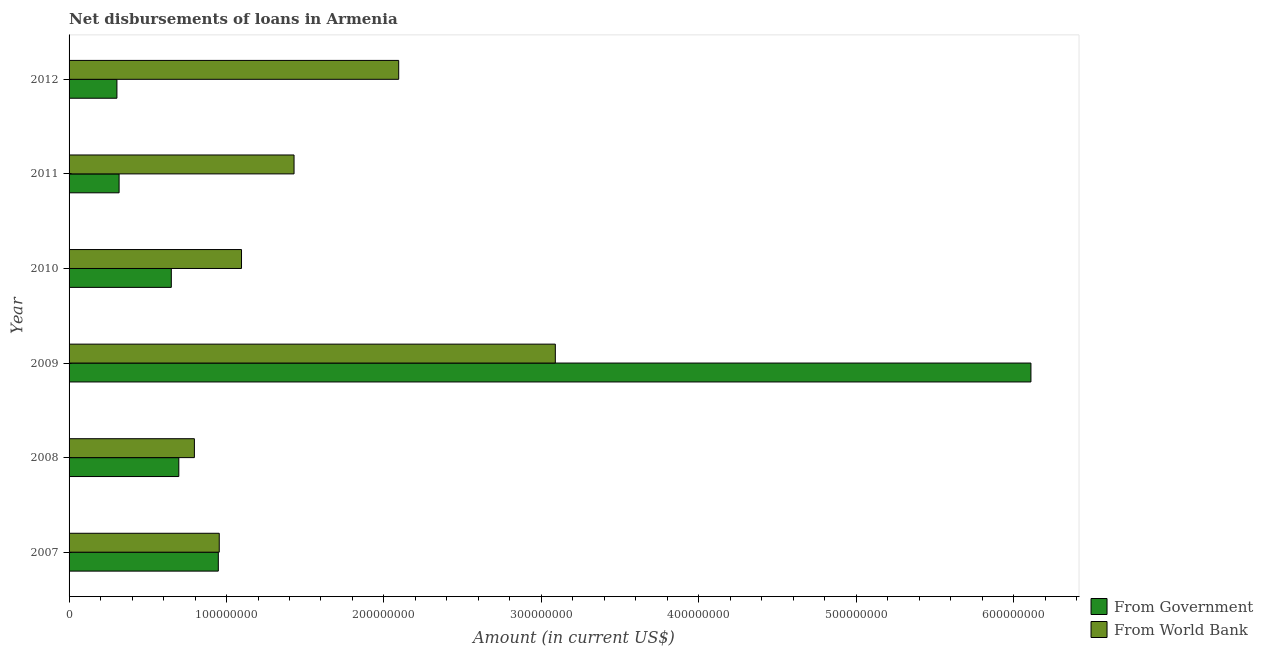How many groups of bars are there?
Provide a short and direct response. 6. Are the number of bars per tick equal to the number of legend labels?
Provide a succinct answer. Yes. Are the number of bars on each tick of the Y-axis equal?
Offer a terse response. Yes. How many bars are there on the 4th tick from the bottom?
Your answer should be compact. 2. What is the net disbursements of loan from government in 2008?
Your response must be concise. 6.97e+07. Across all years, what is the maximum net disbursements of loan from world bank?
Your answer should be very brief. 3.09e+08. Across all years, what is the minimum net disbursements of loan from government?
Give a very brief answer. 3.04e+07. In which year was the net disbursements of loan from world bank maximum?
Provide a succinct answer. 2009. In which year was the net disbursements of loan from world bank minimum?
Your answer should be compact. 2008. What is the total net disbursements of loan from government in the graph?
Give a very brief answer. 9.02e+08. What is the difference between the net disbursements of loan from government in 2007 and that in 2009?
Provide a succinct answer. -5.16e+08. What is the difference between the net disbursements of loan from government in 2007 and the net disbursements of loan from world bank in 2010?
Provide a short and direct response. -1.47e+07. What is the average net disbursements of loan from world bank per year?
Your response must be concise. 1.58e+08. In the year 2012, what is the difference between the net disbursements of loan from government and net disbursements of loan from world bank?
Make the answer very short. -1.79e+08. What is the ratio of the net disbursements of loan from world bank in 2009 to that in 2011?
Your answer should be compact. 2.16. What is the difference between the highest and the second highest net disbursements of loan from world bank?
Your answer should be compact. 9.95e+07. What is the difference between the highest and the lowest net disbursements of loan from world bank?
Provide a short and direct response. 2.29e+08. What does the 1st bar from the top in 2011 represents?
Offer a terse response. From World Bank. What does the 2nd bar from the bottom in 2009 represents?
Provide a short and direct response. From World Bank. How many bars are there?
Keep it short and to the point. 12. Are all the bars in the graph horizontal?
Provide a succinct answer. Yes. How many years are there in the graph?
Offer a terse response. 6. Does the graph contain any zero values?
Your response must be concise. No. Where does the legend appear in the graph?
Give a very brief answer. Bottom right. How many legend labels are there?
Provide a short and direct response. 2. How are the legend labels stacked?
Ensure brevity in your answer.  Vertical. What is the title of the graph?
Your answer should be very brief. Net disbursements of loans in Armenia. Does "Automatic Teller Machines" appear as one of the legend labels in the graph?
Your answer should be very brief. No. What is the label or title of the Y-axis?
Your answer should be very brief. Year. What is the Amount (in current US$) of From Government in 2007?
Keep it short and to the point. 9.48e+07. What is the Amount (in current US$) in From World Bank in 2007?
Ensure brevity in your answer.  9.54e+07. What is the Amount (in current US$) of From Government in 2008?
Provide a short and direct response. 6.97e+07. What is the Amount (in current US$) in From World Bank in 2008?
Your answer should be compact. 7.96e+07. What is the Amount (in current US$) of From Government in 2009?
Ensure brevity in your answer.  6.11e+08. What is the Amount (in current US$) in From World Bank in 2009?
Offer a very short reply. 3.09e+08. What is the Amount (in current US$) in From Government in 2010?
Offer a very short reply. 6.49e+07. What is the Amount (in current US$) of From World Bank in 2010?
Provide a short and direct response. 1.10e+08. What is the Amount (in current US$) in From Government in 2011?
Offer a very short reply. 3.18e+07. What is the Amount (in current US$) in From World Bank in 2011?
Provide a succinct answer. 1.43e+08. What is the Amount (in current US$) in From Government in 2012?
Your response must be concise. 3.04e+07. What is the Amount (in current US$) in From World Bank in 2012?
Ensure brevity in your answer.  2.09e+08. Across all years, what is the maximum Amount (in current US$) in From Government?
Your answer should be very brief. 6.11e+08. Across all years, what is the maximum Amount (in current US$) in From World Bank?
Provide a short and direct response. 3.09e+08. Across all years, what is the minimum Amount (in current US$) of From Government?
Ensure brevity in your answer.  3.04e+07. Across all years, what is the minimum Amount (in current US$) in From World Bank?
Make the answer very short. 7.96e+07. What is the total Amount (in current US$) of From Government in the graph?
Provide a succinct answer. 9.02e+08. What is the total Amount (in current US$) of From World Bank in the graph?
Your answer should be compact. 9.46e+08. What is the difference between the Amount (in current US$) of From Government in 2007 and that in 2008?
Give a very brief answer. 2.51e+07. What is the difference between the Amount (in current US$) in From World Bank in 2007 and that in 2008?
Offer a very short reply. 1.58e+07. What is the difference between the Amount (in current US$) in From Government in 2007 and that in 2009?
Offer a very short reply. -5.16e+08. What is the difference between the Amount (in current US$) in From World Bank in 2007 and that in 2009?
Keep it short and to the point. -2.13e+08. What is the difference between the Amount (in current US$) in From Government in 2007 and that in 2010?
Provide a succinct answer. 2.98e+07. What is the difference between the Amount (in current US$) of From World Bank in 2007 and that in 2010?
Your answer should be very brief. -1.41e+07. What is the difference between the Amount (in current US$) of From Government in 2007 and that in 2011?
Give a very brief answer. 6.30e+07. What is the difference between the Amount (in current US$) of From World Bank in 2007 and that in 2011?
Ensure brevity in your answer.  -4.75e+07. What is the difference between the Amount (in current US$) in From Government in 2007 and that in 2012?
Offer a terse response. 6.44e+07. What is the difference between the Amount (in current US$) of From World Bank in 2007 and that in 2012?
Your response must be concise. -1.14e+08. What is the difference between the Amount (in current US$) in From Government in 2008 and that in 2009?
Your answer should be compact. -5.41e+08. What is the difference between the Amount (in current US$) of From World Bank in 2008 and that in 2009?
Provide a short and direct response. -2.29e+08. What is the difference between the Amount (in current US$) of From Government in 2008 and that in 2010?
Offer a terse response. 4.77e+06. What is the difference between the Amount (in current US$) of From World Bank in 2008 and that in 2010?
Ensure brevity in your answer.  -2.99e+07. What is the difference between the Amount (in current US$) of From Government in 2008 and that in 2011?
Your answer should be very brief. 3.79e+07. What is the difference between the Amount (in current US$) of From World Bank in 2008 and that in 2011?
Give a very brief answer. -6.33e+07. What is the difference between the Amount (in current US$) in From Government in 2008 and that in 2012?
Provide a short and direct response. 3.93e+07. What is the difference between the Amount (in current US$) of From World Bank in 2008 and that in 2012?
Your response must be concise. -1.30e+08. What is the difference between the Amount (in current US$) in From Government in 2009 and that in 2010?
Your response must be concise. 5.46e+08. What is the difference between the Amount (in current US$) in From World Bank in 2009 and that in 2010?
Provide a short and direct response. 1.99e+08. What is the difference between the Amount (in current US$) in From Government in 2009 and that in 2011?
Your response must be concise. 5.79e+08. What is the difference between the Amount (in current US$) of From World Bank in 2009 and that in 2011?
Your answer should be compact. 1.66e+08. What is the difference between the Amount (in current US$) of From Government in 2009 and that in 2012?
Your answer should be compact. 5.81e+08. What is the difference between the Amount (in current US$) in From World Bank in 2009 and that in 2012?
Make the answer very short. 9.95e+07. What is the difference between the Amount (in current US$) of From Government in 2010 and that in 2011?
Your response must be concise. 3.32e+07. What is the difference between the Amount (in current US$) in From World Bank in 2010 and that in 2011?
Your answer should be compact. -3.34e+07. What is the difference between the Amount (in current US$) in From Government in 2010 and that in 2012?
Ensure brevity in your answer.  3.45e+07. What is the difference between the Amount (in current US$) of From World Bank in 2010 and that in 2012?
Offer a terse response. -9.98e+07. What is the difference between the Amount (in current US$) in From Government in 2011 and that in 2012?
Make the answer very short. 1.38e+06. What is the difference between the Amount (in current US$) of From World Bank in 2011 and that in 2012?
Make the answer very short. -6.65e+07. What is the difference between the Amount (in current US$) of From Government in 2007 and the Amount (in current US$) of From World Bank in 2008?
Your answer should be compact. 1.52e+07. What is the difference between the Amount (in current US$) of From Government in 2007 and the Amount (in current US$) of From World Bank in 2009?
Give a very brief answer. -2.14e+08. What is the difference between the Amount (in current US$) in From Government in 2007 and the Amount (in current US$) in From World Bank in 2010?
Your answer should be compact. -1.47e+07. What is the difference between the Amount (in current US$) in From Government in 2007 and the Amount (in current US$) in From World Bank in 2011?
Keep it short and to the point. -4.81e+07. What is the difference between the Amount (in current US$) in From Government in 2007 and the Amount (in current US$) in From World Bank in 2012?
Your answer should be very brief. -1.15e+08. What is the difference between the Amount (in current US$) of From Government in 2008 and the Amount (in current US$) of From World Bank in 2009?
Offer a terse response. -2.39e+08. What is the difference between the Amount (in current US$) in From Government in 2008 and the Amount (in current US$) in From World Bank in 2010?
Offer a terse response. -3.98e+07. What is the difference between the Amount (in current US$) in From Government in 2008 and the Amount (in current US$) in From World Bank in 2011?
Ensure brevity in your answer.  -7.32e+07. What is the difference between the Amount (in current US$) of From Government in 2008 and the Amount (in current US$) of From World Bank in 2012?
Offer a very short reply. -1.40e+08. What is the difference between the Amount (in current US$) of From Government in 2009 and the Amount (in current US$) of From World Bank in 2010?
Provide a succinct answer. 5.01e+08. What is the difference between the Amount (in current US$) in From Government in 2009 and the Amount (in current US$) in From World Bank in 2011?
Keep it short and to the point. 4.68e+08. What is the difference between the Amount (in current US$) of From Government in 2009 and the Amount (in current US$) of From World Bank in 2012?
Offer a very short reply. 4.02e+08. What is the difference between the Amount (in current US$) of From Government in 2010 and the Amount (in current US$) of From World Bank in 2011?
Provide a succinct answer. -7.80e+07. What is the difference between the Amount (in current US$) of From Government in 2010 and the Amount (in current US$) of From World Bank in 2012?
Provide a short and direct response. -1.44e+08. What is the difference between the Amount (in current US$) of From Government in 2011 and the Amount (in current US$) of From World Bank in 2012?
Offer a very short reply. -1.78e+08. What is the average Amount (in current US$) in From Government per year?
Offer a terse response. 1.50e+08. What is the average Amount (in current US$) of From World Bank per year?
Your answer should be compact. 1.58e+08. In the year 2007, what is the difference between the Amount (in current US$) of From Government and Amount (in current US$) of From World Bank?
Your answer should be very brief. -6.03e+05. In the year 2008, what is the difference between the Amount (in current US$) of From Government and Amount (in current US$) of From World Bank?
Provide a succinct answer. -9.89e+06. In the year 2009, what is the difference between the Amount (in current US$) of From Government and Amount (in current US$) of From World Bank?
Provide a short and direct response. 3.02e+08. In the year 2010, what is the difference between the Amount (in current US$) in From Government and Amount (in current US$) in From World Bank?
Your answer should be compact. -4.46e+07. In the year 2011, what is the difference between the Amount (in current US$) in From Government and Amount (in current US$) in From World Bank?
Offer a terse response. -1.11e+08. In the year 2012, what is the difference between the Amount (in current US$) of From Government and Amount (in current US$) of From World Bank?
Your answer should be very brief. -1.79e+08. What is the ratio of the Amount (in current US$) of From Government in 2007 to that in 2008?
Your answer should be compact. 1.36. What is the ratio of the Amount (in current US$) of From World Bank in 2007 to that in 2008?
Ensure brevity in your answer.  1.2. What is the ratio of the Amount (in current US$) of From Government in 2007 to that in 2009?
Your response must be concise. 0.16. What is the ratio of the Amount (in current US$) of From World Bank in 2007 to that in 2009?
Your response must be concise. 0.31. What is the ratio of the Amount (in current US$) of From Government in 2007 to that in 2010?
Your response must be concise. 1.46. What is the ratio of the Amount (in current US$) of From World Bank in 2007 to that in 2010?
Make the answer very short. 0.87. What is the ratio of the Amount (in current US$) of From Government in 2007 to that in 2011?
Provide a short and direct response. 2.98. What is the ratio of the Amount (in current US$) of From World Bank in 2007 to that in 2011?
Your answer should be very brief. 0.67. What is the ratio of the Amount (in current US$) in From Government in 2007 to that in 2012?
Provide a short and direct response. 3.12. What is the ratio of the Amount (in current US$) of From World Bank in 2007 to that in 2012?
Your answer should be very brief. 0.46. What is the ratio of the Amount (in current US$) in From Government in 2008 to that in 2009?
Provide a short and direct response. 0.11. What is the ratio of the Amount (in current US$) in From World Bank in 2008 to that in 2009?
Ensure brevity in your answer.  0.26. What is the ratio of the Amount (in current US$) in From Government in 2008 to that in 2010?
Your answer should be very brief. 1.07. What is the ratio of the Amount (in current US$) in From World Bank in 2008 to that in 2010?
Make the answer very short. 0.73. What is the ratio of the Amount (in current US$) of From Government in 2008 to that in 2011?
Your answer should be compact. 2.19. What is the ratio of the Amount (in current US$) in From World Bank in 2008 to that in 2011?
Your answer should be very brief. 0.56. What is the ratio of the Amount (in current US$) of From Government in 2008 to that in 2012?
Offer a very short reply. 2.29. What is the ratio of the Amount (in current US$) in From World Bank in 2008 to that in 2012?
Give a very brief answer. 0.38. What is the ratio of the Amount (in current US$) of From Government in 2009 to that in 2010?
Give a very brief answer. 9.41. What is the ratio of the Amount (in current US$) in From World Bank in 2009 to that in 2010?
Give a very brief answer. 2.82. What is the ratio of the Amount (in current US$) of From Government in 2009 to that in 2011?
Offer a terse response. 19.23. What is the ratio of the Amount (in current US$) of From World Bank in 2009 to that in 2011?
Provide a succinct answer. 2.16. What is the ratio of the Amount (in current US$) of From Government in 2009 to that in 2012?
Keep it short and to the point. 20.1. What is the ratio of the Amount (in current US$) of From World Bank in 2009 to that in 2012?
Your answer should be very brief. 1.48. What is the ratio of the Amount (in current US$) in From Government in 2010 to that in 2011?
Ensure brevity in your answer.  2.04. What is the ratio of the Amount (in current US$) of From World Bank in 2010 to that in 2011?
Your answer should be very brief. 0.77. What is the ratio of the Amount (in current US$) of From Government in 2010 to that in 2012?
Give a very brief answer. 2.14. What is the ratio of the Amount (in current US$) in From World Bank in 2010 to that in 2012?
Offer a very short reply. 0.52. What is the ratio of the Amount (in current US$) in From Government in 2011 to that in 2012?
Give a very brief answer. 1.05. What is the ratio of the Amount (in current US$) of From World Bank in 2011 to that in 2012?
Your response must be concise. 0.68. What is the difference between the highest and the second highest Amount (in current US$) in From Government?
Your response must be concise. 5.16e+08. What is the difference between the highest and the second highest Amount (in current US$) in From World Bank?
Ensure brevity in your answer.  9.95e+07. What is the difference between the highest and the lowest Amount (in current US$) of From Government?
Ensure brevity in your answer.  5.81e+08. What is the difference between the highest and the lowest Amount (in current US$) of From World Bank?
Your answer should be compact. 2.29e+08. 